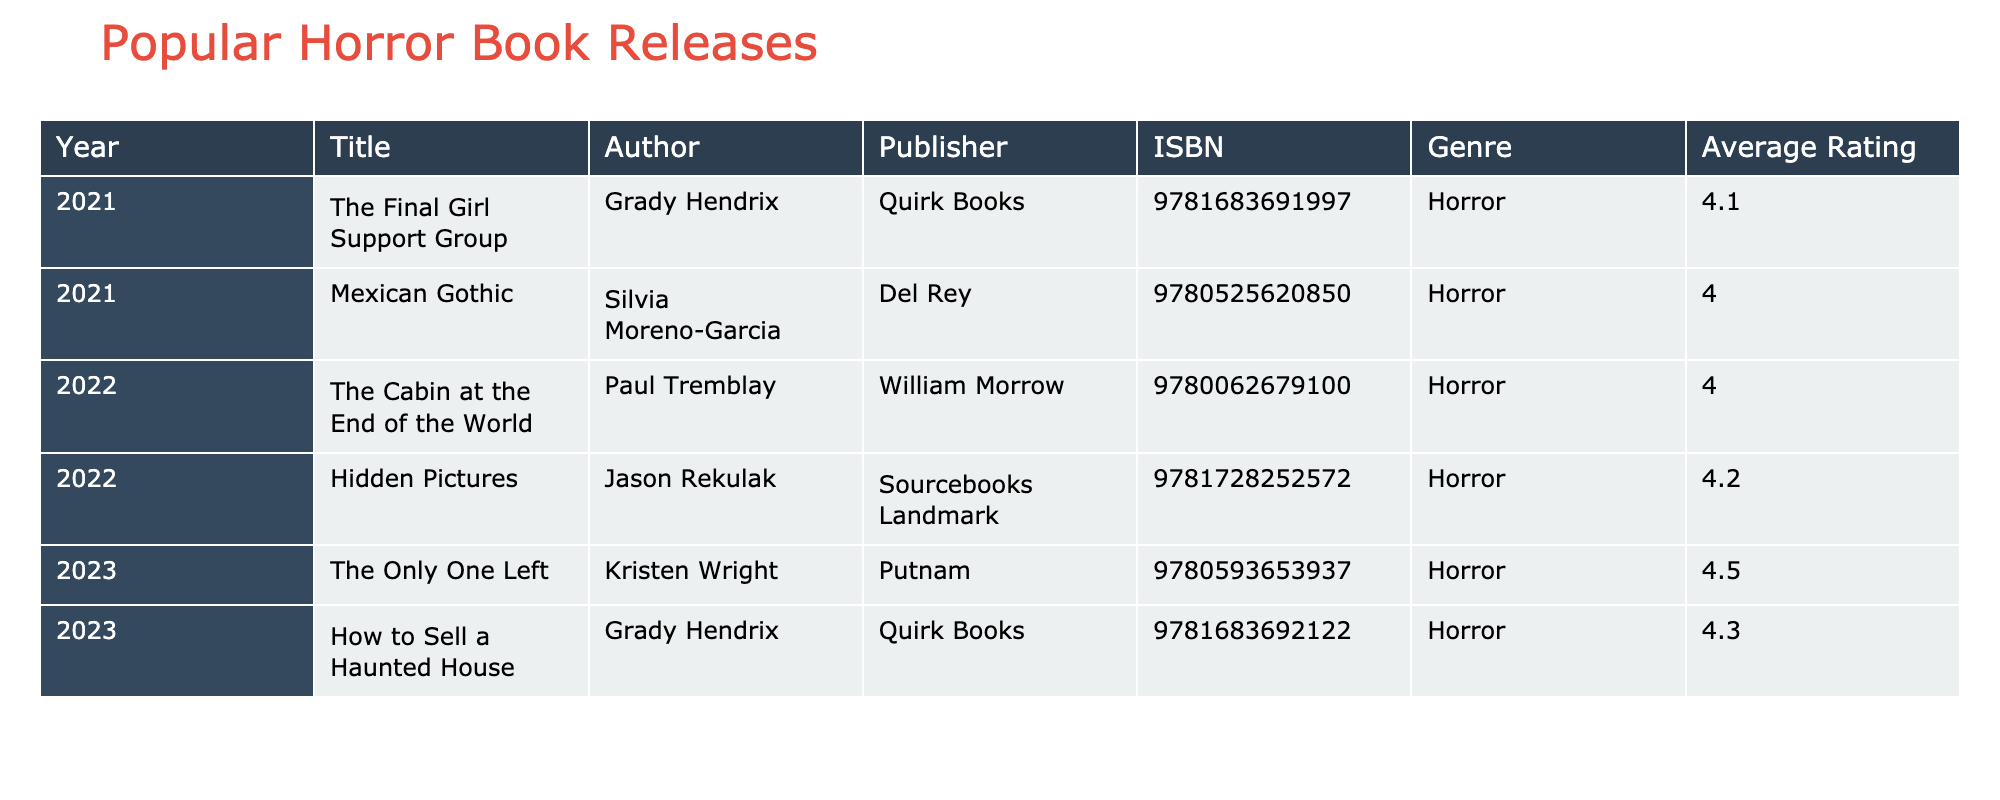What is the title of the highest-rated horror book in the table? To find the highest-rated horror book, we check the "Average Rating" column for the highest value. The book with the highest average rating is "The Only One Left" with a rating of 4.5.
Answer: The Only One Left Which author published the book "Mexican Gothic"? The "Author" column indicates the author of each book. For "Mexican Gothic," the author listed is Silvia Moreno-Garcia.
Answer: Silvia Moreno-Garcia How many books were released in 2022? By looking at the "Year" column, we can count the number of entries for the year 2022. There are two titles: "The Cabin at the End of the World" and "Hidden Pictures."
Answer: 2 What is the average rating of all the horror books listed? To calculate the average rating, we sum the ratings: (4.1 + 4.0 + 4.0 + 4.2 + 4.5 + 4.3) = 24.1. There are six books, so the average is 24.1 / 6 = 4.0167, which rounds to 4.0.
Answer: 4.0 Is "The Final Girl Support Group" published by Quirk Books? Looking at the table, we see that "The Final Girl Support Group" does list Quirk Books as the publisher. This confirms it is true.
Answer: Yes Which year saw the most horror book releases? We check the "Year" column and count the entries for each year. In 2021, there are two releases, in 2022 there are two, and in 2023 there are two as well. Since all years have the same number of releases, no specific year has more than the others.
Answer: No specific year has the most releases How many authors contributed to the books listed in the table? Looking at the "Author" column, we identify unique authors: Grady Hendrix, Silvia Moreno-Garcia, Paul Tremblay, Jason Rekulak, Kristen Wright. Counting these gives us five unique authors.
Answer: 5 Did any book released in 2023 have a rating lower than 4.5? We check the ratings for books released in 2023: "The Only One Left" has a rating of 4.5, and "How to Sell a Haunted House" has a rating of 4.3. Since one book does have a lower rating, the answer is true.
Answer: Yes 